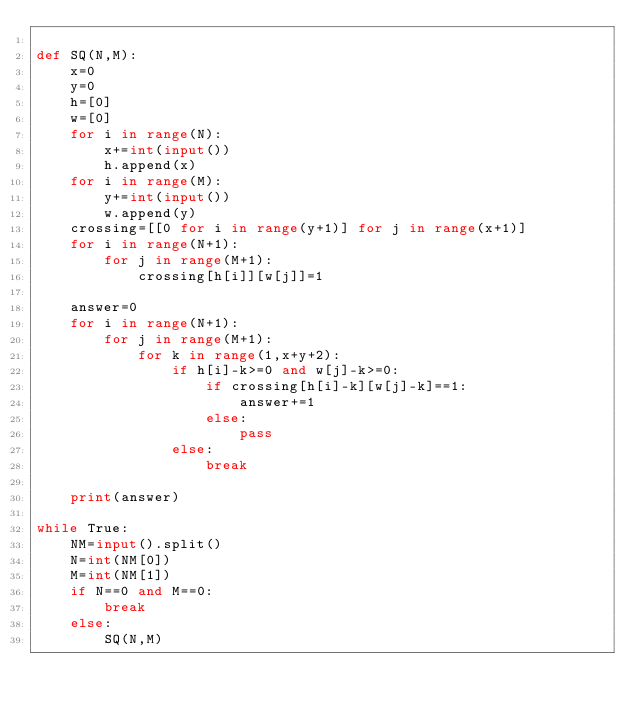Convert code to text. <code><loc_0><loc_0><loc_500><loc_500><_Python_>
def SQ(N,M):
    x=0
    y=0
    h=[0]
    w=[0]
    for i in range(N):
        x+=int(input())
        h.append(x)
    for i in range(M):
        y+=int(input())
        w.append(y)
    crossing=[[0 for i in range(y+1)] for j in range(x+1)]
    for i in range(N+1):
        for j in range(M+1):
            crossing[h[i]][w[j]]=1

    answer=0
    for i in range(N+1):
        for j in range(M+1):
            for k in range(1,x+y+2):
                if h[i]-k>=0 and w[j]-k>=0:
                    if crossing[h[i]-k][w[j]-k]==1:
                        answer+=1
                    else:
                        pass
                else:
                    break

    print(answer)

while True:
    NM=input().split()
    N=int(NM[0])
    M=int(NM[1])
    if N==0 and M==0:
        break
    else:
        SQ(N,M)

</code> 